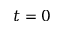<formula> <loc_0><loc_0><loc_500><loc_500>t = 0</formula> 